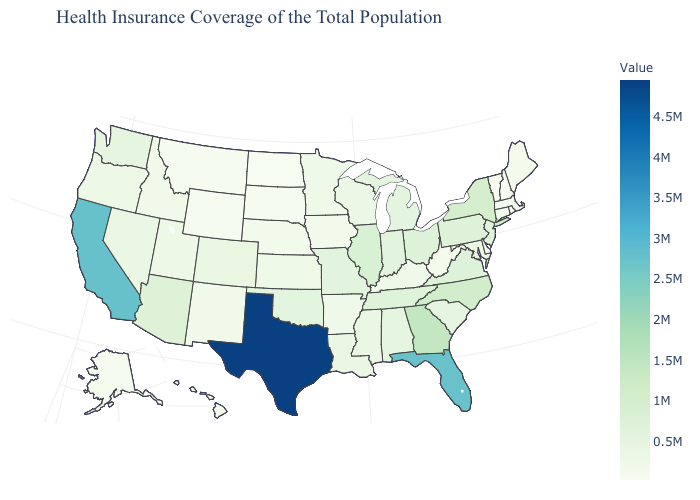Among the states that border Utah , does New Mexico have the highest value?
Concise answer only. No. Among the states that border Tennessee , does Kentucky have the lowest value?
Keep it brief. Yes. Does Florida have a higher value than Texas?
Give a very brief answer. No. Does Texas have the highest value in the USA?
Concise answer only. Yes. Among the states that border Wisconsin , does Michigan have the lowest value?
Give a very brief answer. No. Which states have the highest value in the USA?
Short answer required. Texas. 